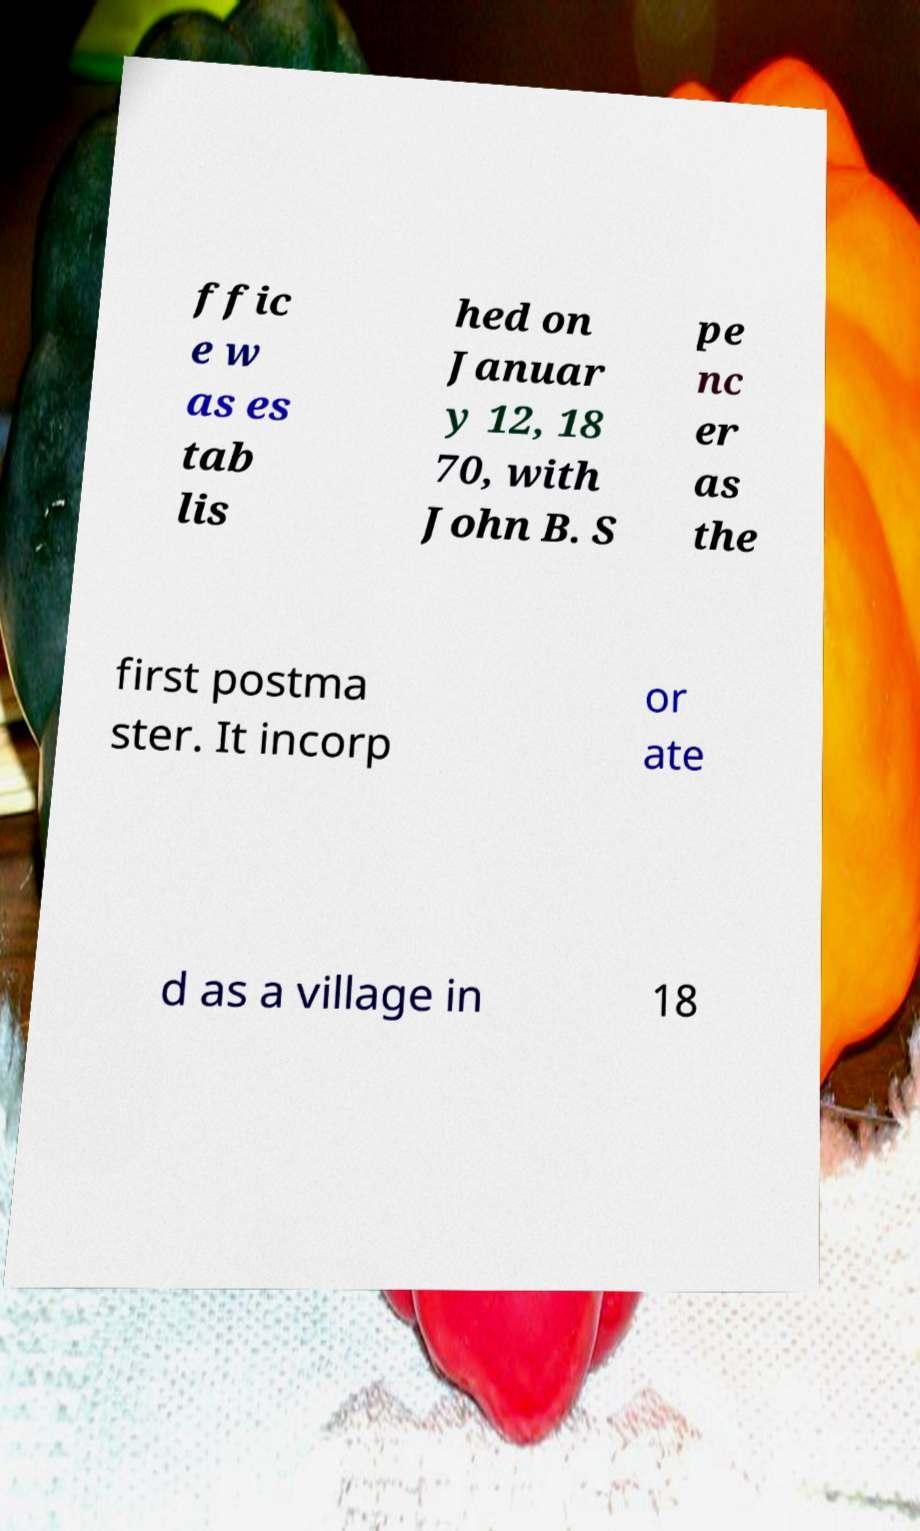I need the written content from this picture converted into text. Can you do that? ffic e w as es tab lis hed on Januar y 12, 18 70, with John B. S pe nc er as the first postma ster. It incorp or ate d as a village in 18 